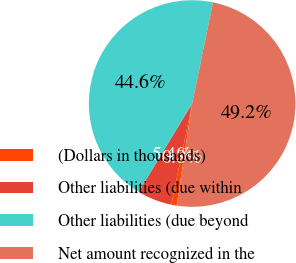<chart> <loc_0><loc_0><loc_500><loc_500><pie_chart><fcel>(Dollars in thousands)<fcel>Other liabilities (due within<fcel>Other liabilities (due beyond<fcel>Net amount recognized in the<nl><fcel>0.83%<fcel>5.43%<fcel>44.57%<fcel>49.17%<nl></chart> 